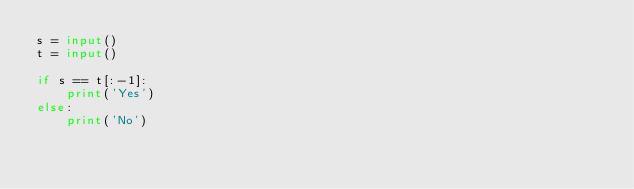<code> <loc_0><loc_0><loc_500><loc_500><_Python_>s = input()
t = input()

if s == t[:-1]:
    print('Yes')
else:
    print('No')</code> 